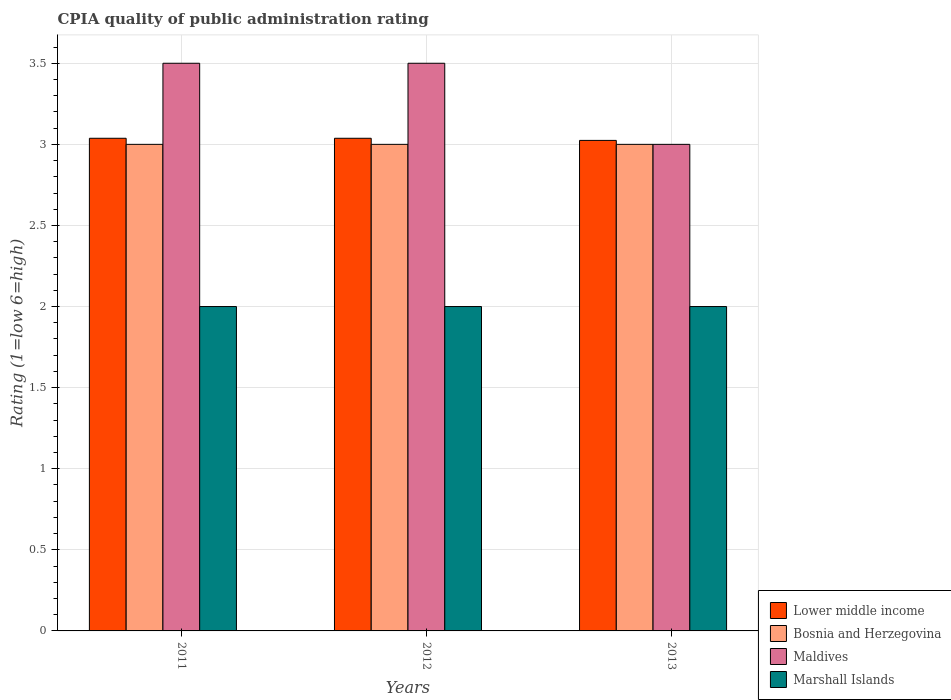How many different coloured bars are there?
Give a very brief answer. 4. Are the number of bars on each tick of the X-axis equal?
Your response must be concise. Yes. How many bars are there on the 3rd tick from the left?
Your response must be concise. 4. How many bars are there on the 2nd tick from the right?
Give a very brief answer. 4. What is the label of the 2nd group of bars from the left?
Your response must be concise. 2012. In how many cases, is the number of bars for a given year not equal to the number of legend labels?
Offer a very short reply. 0. What is the CPIA rating in Lower middle income in 2011?
Provide a succinct answer. 3.04. Across all years, what is the minimum CPIA rating in Marshall Islands?
Provide a short and direct response. 2. In which year was the CPIA rating in Marshall Islands maximum?
Your answer should be compact. 2011. What is the difference between the CPIA rating in Bosnia and Herzegovina in 2011 and that in 2013?
Offer a very short reply. 0. In the year 2013, what is the difference between the CPIA rating in Marshall Islands and CPIA rating in Bosnia and Herzegovina?
Offer a terse response. -1. What is the ratio of the CPIA rating in Lower middle income in 2012 to that in 2013?
Provide a succinct answer. 1. Is the difference between the CPIA rating in Marshall Islands in 2012 and 2013 greater than the difference between the CPIA rating in Bosnia and Herzegovina in 2012 and 2013?
Your answer should be very brief. No. What is the difference between the highest and the second highest CPIA rating in Maldives?
Make the answer very short. 0. What is the difference between the highest and the lowest CPIA rating in Lower middle income?
Your response must be concise. 0.01. What does the 1st bar from the left in 2013 represents?
Ensure brevity in your answer.  Lower middle income. What does the 1st bar from the right in 2012 represents?
Offer a terse response. Marshall Islands. How many years are there in the graph?
Make the answer very short. 3. What is the difference between two consecutive major ticks on the Y-axis?
Make the answer very short. 0.5. Are the values on the major ticks of Y-axis written in scientific E-notation?
Give a very brief answer. No. Does the graph contain any zero values?
Give a very brief answer. No. Where does the legend appear in the graph?
Your answer should be compact. Bottom right. What is the title of the graph?
Your answer should be very brief. CPIA quality of public administration rating. Does "Egypt, Arab Rep." appear as one of the legend labels in the graph?
Give a very brief answer. No. What is the label or title of the X-axis?
Your response must be concise. Years. What is the Rating (1=low 6=high) in Lower middle income in 2011?
Make the answer very short. 3.04. What is the Rating (1=low 6=high) of Bosnia and Herzegovina in 2011?
Provide a short and direct response. 3. What is the Rating (1=low 6=high) of Marshall Islands in 2011?
Make the answer very short. 2. What is the Rating (1=low 6=high) of Lower middle income in 2012?
Offer a terse response. 3.04. What is the Rating (1=low 6=high) of Bosnia and Herzegovina in 2012?
Your answer should be compact. 3. What is the Rating (1=low 6=high) of Maldives in 2012?
Provide a succinct answer. 3.5. What is the Rating (1=low 6=high) of Lower middle income in 2013?
Give a very brief answer. 3.02. What is the Rating (1=low 6=high) of Bosnia and Herzegovina in 2013?
Provide a succinct answer. 3. What is the Rating (1=low 6=high) in Maldives in 2013?
Offer a terse response. 3. What is the Rating (1=low 6=high) in Marshall Islands in 2013?
Your response must be concise. 2. Across all years, what is the maximum Rating (1=low 6=high) in Lower middle income?
Your response must be concise. 3.04. Across all years, what is the maximum Rating (1=low 6=high) of Bosnia and Herzegovina?
Provide a succinct answer. 3. Across all years, what is the maximum Rating (1=low 6=high) of Maldives?
Ensure brevity in your answer.  3.5. Across all years, what is the maximum Rating (1=low 6=high) of Marshall Islands?
Ensure brevity in your answer.  2. Across all years, what is the minimum Rating (1=low 6=high) of Lower middle income?
Offer a very short reply. 3.02. Across all years, what is the minimum Rating (1=low 6=high) of Bosnia and Herzegovina?
Make the answer very short. 3. Across all years, what is the minimum Rating (1=low 6=high) of Marshall Islands?
Your answer should be compact. 2. What is the total Rating (1=low 6=high) of Lower middle income in the graph?
Give a very brief answer. 9.1. What is the total Rating (1=low 6=high) in Maldives in the graph?
Offer a very short reply. 10. What is the total Rating (1=low 6=high) in Marshall Islands in the graph?
Provide a short and direct response. 6. What is the difference between the Rating (1=low 6=high) in Maldives in 2011 and that in 2012?
Offer a terse response. 0. What is the difference between the Rating (1=low 6=high) in Lower middle income in 2011 and that in 2013?
Give a very brief answer. 0.01. What is the difference between the Rating (1=low 6=high) in Bosnia and Herzegovina in 2011 and that in 2013?
Keep it short and to the point. 0. What is the difference between the Rating (1=low 6=high) of Lower middle income in 2012 and that in 2013?
Offer a terse response. 0.01. What is the difference between the Rating (1=low 6=high) in Bosnia and Herzegovina in 2012 and that in 2013?
Offer a terse response. 0. What is the difference between the Rating (1=low 6=high) of Marshall Islands in 2012 and that in 2013?
Provide a succinct answer. 0. What is the difference between the Rating (1=low 6=high) of Lower middle income in 2011 and the Rating (1=low 6=high) of Bosnia and Herzegovina in 2012?
Keep it short and to the point. 0.04. What is the difference between the Rating (1=low 6=high) in Lower middle income in 2011 and the Rating (1=low 6=high) in Maldives in 2012?
Offer a terse response. -0.46. What is the difference between the Rating (1=low 6=high) in Lower middle income in 2011 and the Rating (1=low 6=high) in Marshall Islands in 2012?
Your answer should be compact. 1.04. What is the difference between the Rating (1=low 6=high) of Maldives in 2011 and the Rating (1=low 6=high) of Marshall Islands in 2012?
Your answer should be compact. 1.5. What is the difference between the Rating (1=low 6=high) of Lower middle income in 2011 and the Rating (1=low 6=high) of Bosnia and Herzegovina in 2013?
Your answer should be very brief. 0.04. What is the difference between the Rating (1=low 6=high) of Lower middle income in 2011 and the Rating (1=low 6=high) of Maldives in 2013?
Offer a very short reply. 0.04. What is the difference between the Rating (1=low 6=high) in Lower middle income in 2011 and the Rating (1=low 6=high) in Marshall Islands in 2013?
Ensure brevity in your answer.  1.04. What is the difference between the Rating (1=low 6=high) in Bosnia and Herzegovina in 2011 and the Rating (1=low 6=high) in Marshall Islands in 2013?
Give a very brief answer. 1. What is the difference between the Rating (1=low 6=high) of Lower middle income in 2012 and the Rating (1=low 6=high) of Bosnia and Herzegovina in 2013?
Offer a very short reply. 0.04. What is the difference between the Rating (1=low 6=high) of Lower middle income in 2012 and the Rating (1=low 6=high) of Maldives in 2013?
Your response must be concise. 0.04. What is the difference between the Rating (1=low 6=high) of Lower middle income in 2012 and the Rating (1=low 6=high) of Marshall Islands in 2013?
Give a very brief answer. 1.04. What is the difference between the Rating (1=low 6=high) in Bosnia and Herzegovina in 2012 and the Rating (1=low 6=high) in Maldives in 2013?
Give a very brief answer. 0. What is the average Rating (1=low 6=high) of Lower middle income per year?
Your answer should be very brief. 3.03. What is the average Rating (1=low 6=high) of Maldives per year?
Offer a very short reply. 3.33. In the year 2011, what is the difference between the Rating (1=low 6=high) of Lower middle income and Rating (1=low 6=high) of Bosnia and Herzegovina?
Your answer should be very brief. 0.04. In the year 2011, what is the difference between the Rating (1=low 6=high) of Lower middle income and Rating (1=low 6=high) of Maldives?
Keep it short and to the point. -0.46. In the year 2011, what is the difference between the Rating (1=low 6=high) of Lower middle income and Rating (1=low 6=high) of Marshall Islands?
Your answer should be very brief. 1.04. In the year 2011, what is the difference between the Rating (1=low 6=high) of Maldives and Rating (1=low 6=high) of Marshall Islands?
Your answer should be very brief. 1.5. In the year 2012, what is the difference between the Rating (1=low 6=high) of Lower middle income and Rating (1=low 6=high) of Bosnia and Herzegovina?
Your answer should be very brief. 0.04. In the year 2012, what is the difference between the Rating (1=low 6=high) in Lower middle income and Rating (1=low 6=high) in Maldives?
Your answer should be compact. -0.46. In the year 2012, what is the difference between the Rating (1=low 6=high) in Lower middle income and Rating (1=low 6=high) in Marshall Islands?
Give a very brief answer. 1.04. In the year 2012, what is the difference between the Rating (1=low 6=high) in Bosnia and Herzegovina and Rating (1=low 6=high) in Marshall Islands?
Your answer should be compact. 1. In the year 2013, what is the difference between the Rating (1=low 6=high) of Lower middle income and Rating (1=low 6=high) of Bosnia and Herzegovina?
Ensure brevity in your answer.  0.02. In the year 2013, what is the difference between the Rating (1=low 6=high) of Lower middle income and Rating (1=low 6=high) of Maldives?
Provide a succinct answer. 0.02. In the year 2013, what is the difference between the Rating (1=low 6=high) of Lower middle income and Rating (1=low 6=high) of Marshall Islands?
Provide a short and direct response. 1.02. What is the ratio of the Rating (1=low 6=high) of Bosnia and Herzegovina in 2011 to that in 2012?
Your answer should be compact. 1. What is the ratio of the Rating (1=low 6=high) in Maldives in 2011 to that in 2012?
Your response must be concise. 1. What is the ratio of the Rating (1=low 6=high) in Lower middle income in 2011 to that in 2013?
Offer a very short reply. 1. What is the ratio of the Rating (1=low 6=high) of Maldives in 2011 to that in 2013?
Ensure brevity in your answer.  1.17. What is the ratio of the Rating (1=low 6=high) of Marshall Islands in 2011 to that in 2013?
Keep it short and to the point. 1. What is the ratio of the Rating (1=low 6=high) of Lower middle income in 2012 to that in 2013?
Offer a terse response. 1. What is the ratio of the Rating (1=low 6=high) in Bosnia and Herzegovina in 2012 to that in 2013?
Your response must be concise. 1. What is the ratio of the Rating (1=low 6=high) of Marshall Islands in 2012 to that in 2013?
Your response must be concise. 1. What is the difference between the highest and the second highest Rating (1=low 6=high) of Maldives?
Make the answer very short. 0. What is the difference between the highest and the lowest Rating (1=low 6=high) of Lower middle income?
Your answer should be very brief. 0.01. What is the difference between the highest and the lowest Rating (1=low 6=high) in Bosnia and Herzegovina?
Offer a very short reply. 0. What is the difference between the highest and the lowest Rating (1=low 6=high) in Marshall Islands?
Make the answer very short. 0. 